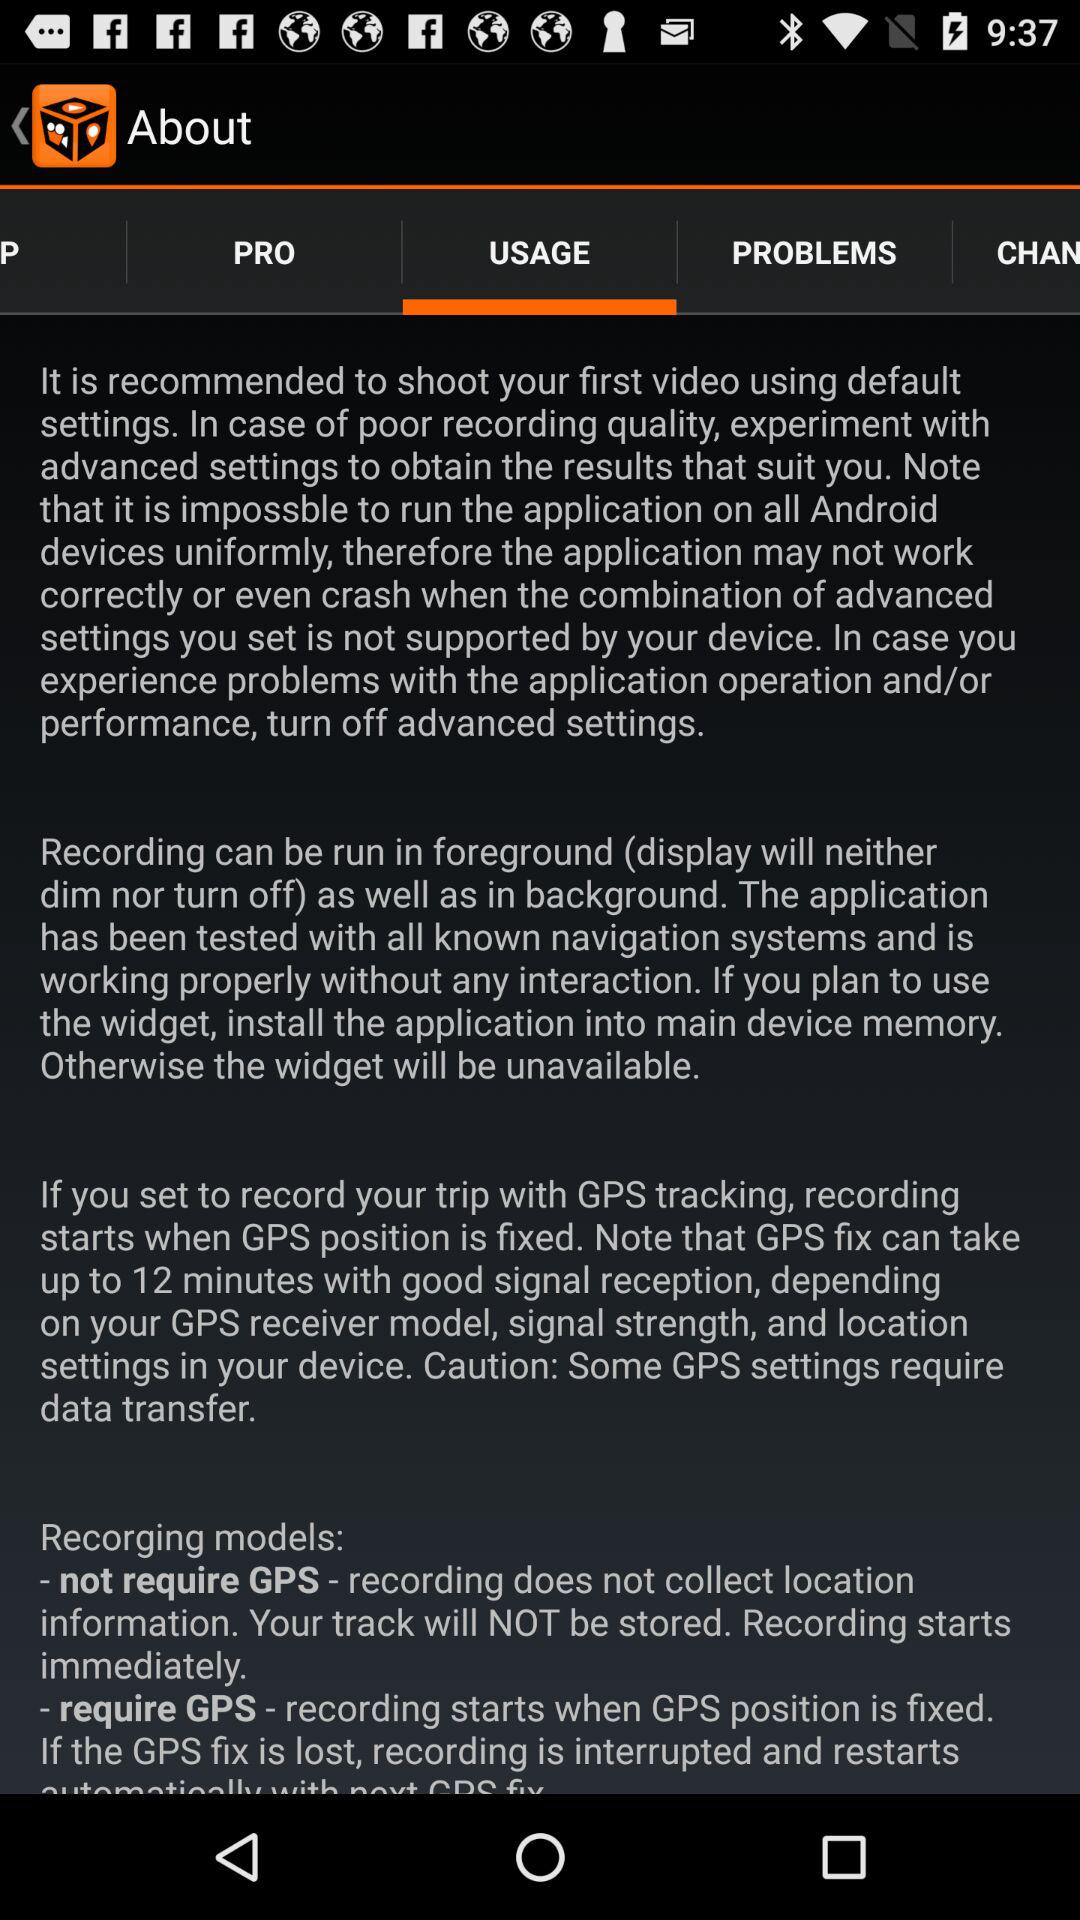How many recording models are available?
Answer the question using a single word or phrase. 2 